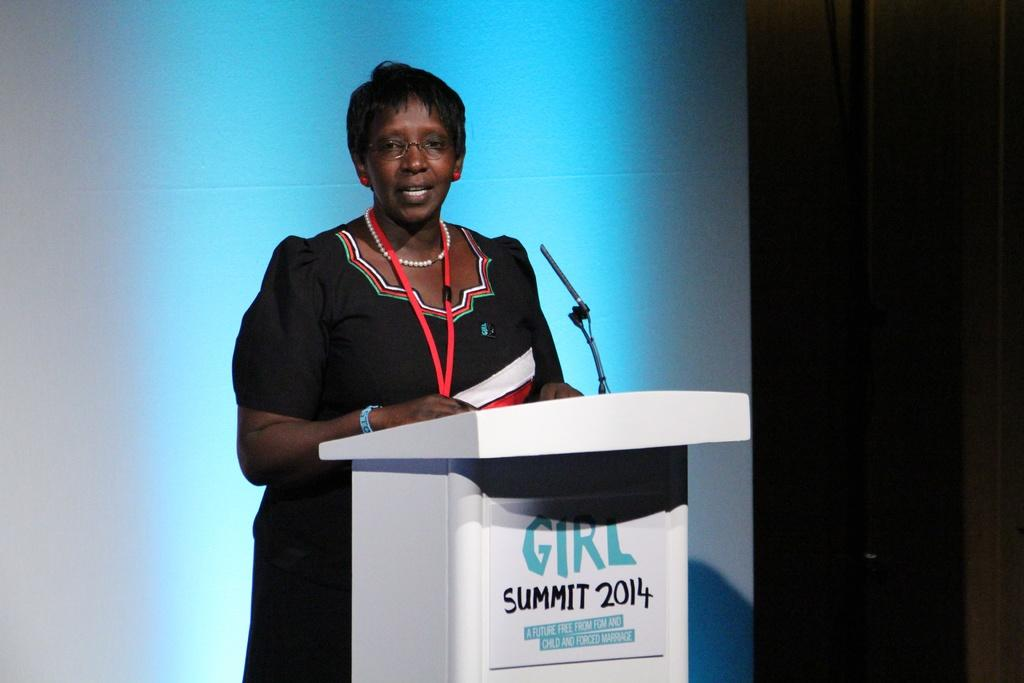<image>
Give a short and clear explanation of the subsequent image. A woman is standing at a podium that says, 'Girl Summit 2014'. 